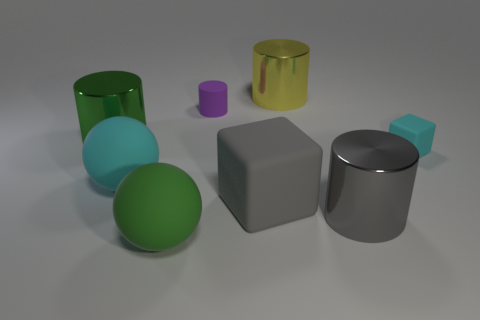Add 2 gray shiny cylinders. How many objects exist? 10 Subtract all cubes. How many objects are left? 6 Subtract all big brown metallic cylinders. Subtract all small cyan things. How many objects are left? 7 Add 7 cyan cubes. How many cyan cubes are left? 8 Add 2 red shiny blocks. How many red shiny blocks exist? 2 Subtract 0 purple cubes. How many objects are left? 8 